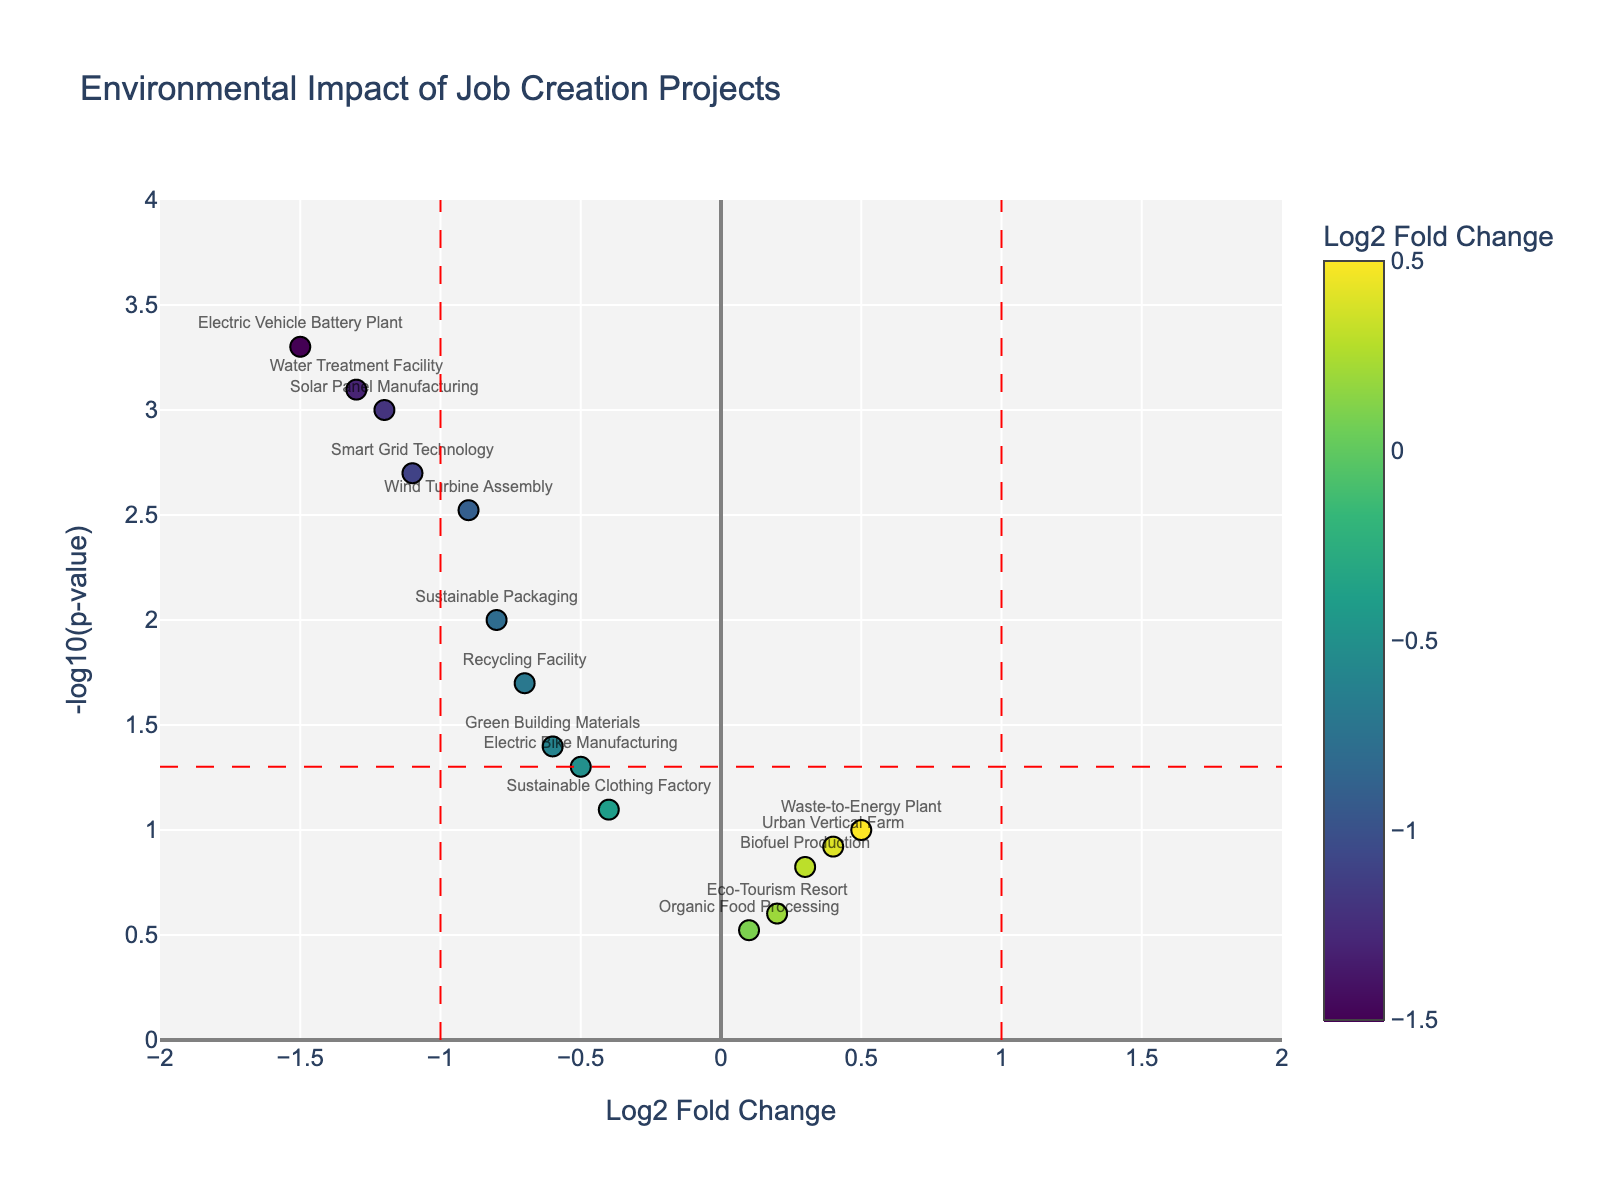What is the title of the plot? The title is located at the top of the plot in a bigger font size compared to other texts. It summarizes the main subject of the plot, which is the environmental impact of job creation projects.
Answer: Environmental Impact of Job Creation Projects How are the Log2 Fold Change values color-coded in the plot? The colors of the data points are determined by their Log2 Fold Change values, with a color scale shown on the right of the plot. The exact coloring scheme is based on a Viridis colorscale, where different values correspond to different colors.
Answer: Viridis colorscale Which project shows the most significant reduction in pollution levels? Look for the data point with the smallest Log2 Fold Change (most negative) and the highest significance (highest -log10(p-value)). It corresponds to the project with the largest negative Log2 Fold Change and lowest p-value.
Answer: Electric Vehicle Battery Plant How many projects have a p-value less than 0.05? Count the number of data points above the horizontal red dashed line, which represents the p-value threshold of 0.05 (translated as -log10(p-value) = 1.3).
Answer: 8 Which project has the highest p-value? Find the data point that is closest to the bottom of the plot since a higher p-value corresponds to a lower -log10(p-value).
Answer: Organic Food Processing What is the Log2 Fold Change of the Smart Grid Technology project? Locate the data point labeled 'Smart Grid Technology' and read its position on the x-axis, which represents the Log2 Fold Change.
Answer: -1.1 Compare the pollution levels of the Waste-to-Energy Plant and the Sustainable Clothing Factory. Which has a higher Log2 Fold Change value? Check the x-axis positions for both 'Waste-to-Energy Plant' and 'Sustainable Clothing Factory'. The higher Log2 Fold Change value will be further to the right.
Answer: Waste-to-Energy Plant Which projects have Log2 Fold Change values close to zero and a high p-value? Locate data points near the vertical zero line on the x-axis and near the bottom of the plot on the y-axis. These points have Log2 Fold Change values close to zero and high p-values.
Answer: Organic Food Processing, Eco-Tourism Resort, Biofuel Production How many projects have a Log2 Fold Change less than -1 and a p-value less than 0.01? Identify data points in the left side of the vertical red dashed line at x = -1 and above the horizontal red dashed line corresponding to p-value < 0.01 (-log10(p-value) > 2).
Answer: 4 What does the position of a data point on the x-axis and y-axis represent? The x-axis position indicates the Log2 Fold Change of pollutant levels before and after project implementation. The y-axis position indicates the significance of this change, represented as -log10(p-value).
Answer: Log2 Fold Change and -log10(p-value) 